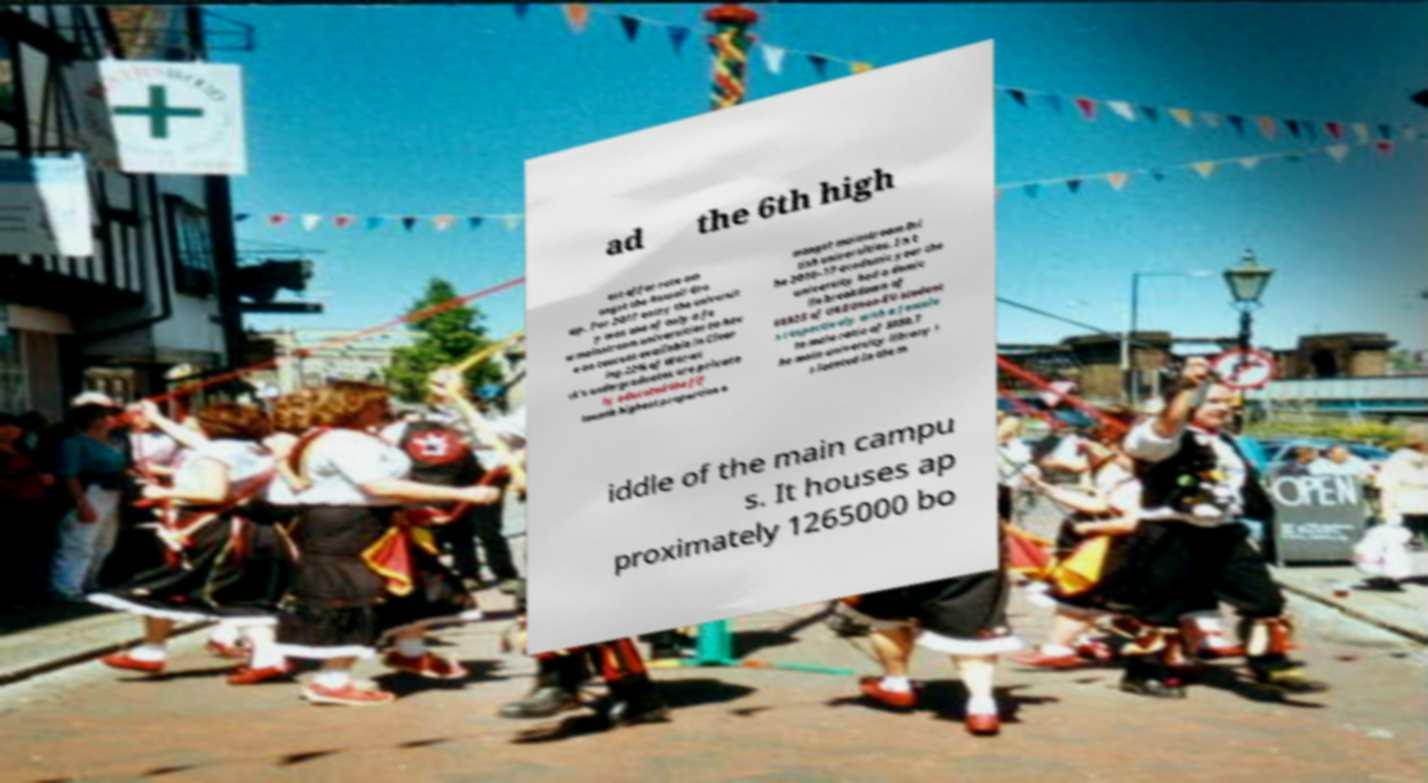Could you extract and type out the text from this image? ad the 6th high est offer rate am ongst the Russell Gro up. For 2017 entry the universit y was one of only a fe w mainstream universities to hav e no courses available in Clear ing.22% of Warwi ck's undergraduates are private ly educated the fif teenth highest proportion a mongst mainstream Bri tish universities. In t he 2016–17 academic year the university had a domic ile breakdown of 66925 of UKEUnon-EU student s respectively with a female to male ratio of 5050.T he main university library i s located in the m iddle of the main campu s. It houses ap proximately 1265000 bo 